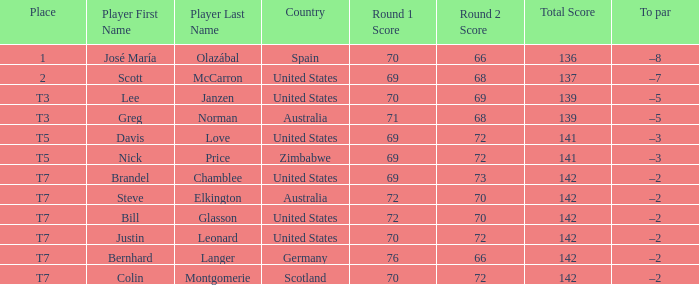Name the Player who has a Country of united states, and a To par of –5? Lee Janzen. 